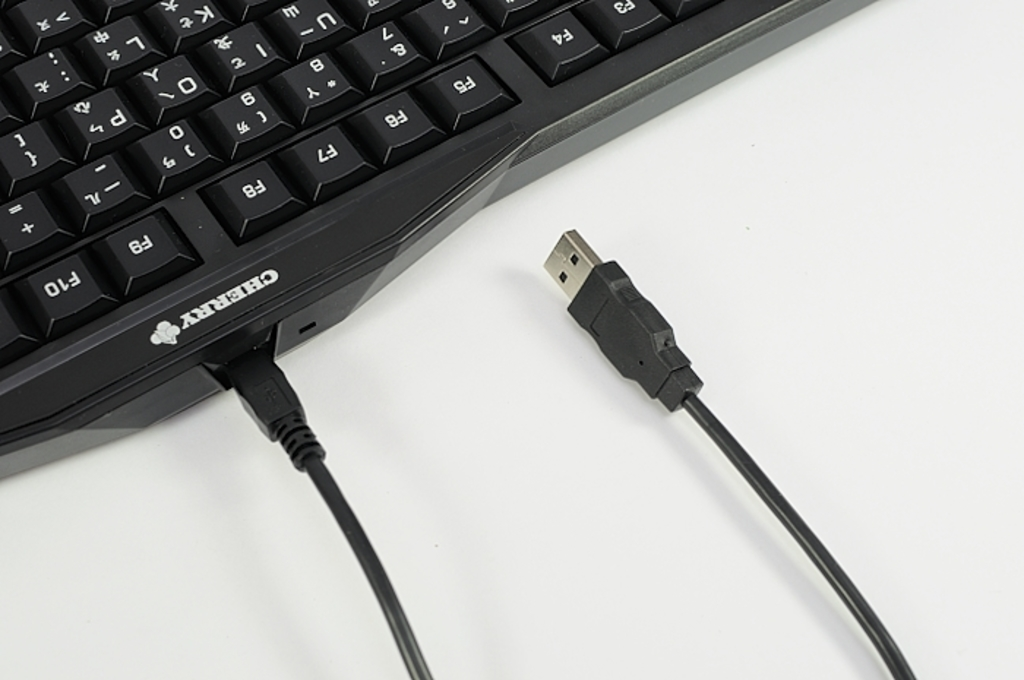What type of device can this keyboard be used with? This keyboard, equipped with a USB type-A connector, can be used with a wide range of devices including desktop computers, laptops, and any host device that supports a USB interface. Is this keyboard suitable for gaming? Yes, while not specifically marketed as a gaming keyboard, its Cherry brand is well-regarded for durability and responsiveness, making it suitable for gaming as well as general use. 